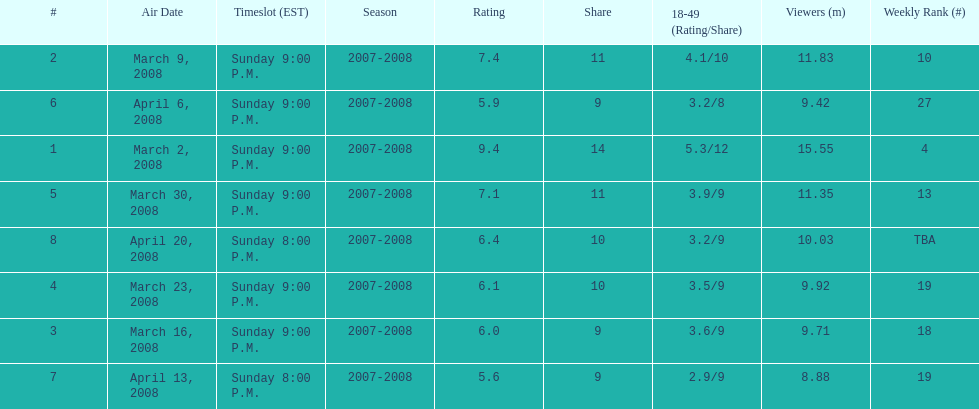Did the season finish at an earlier or later timeslot? Earlier. 